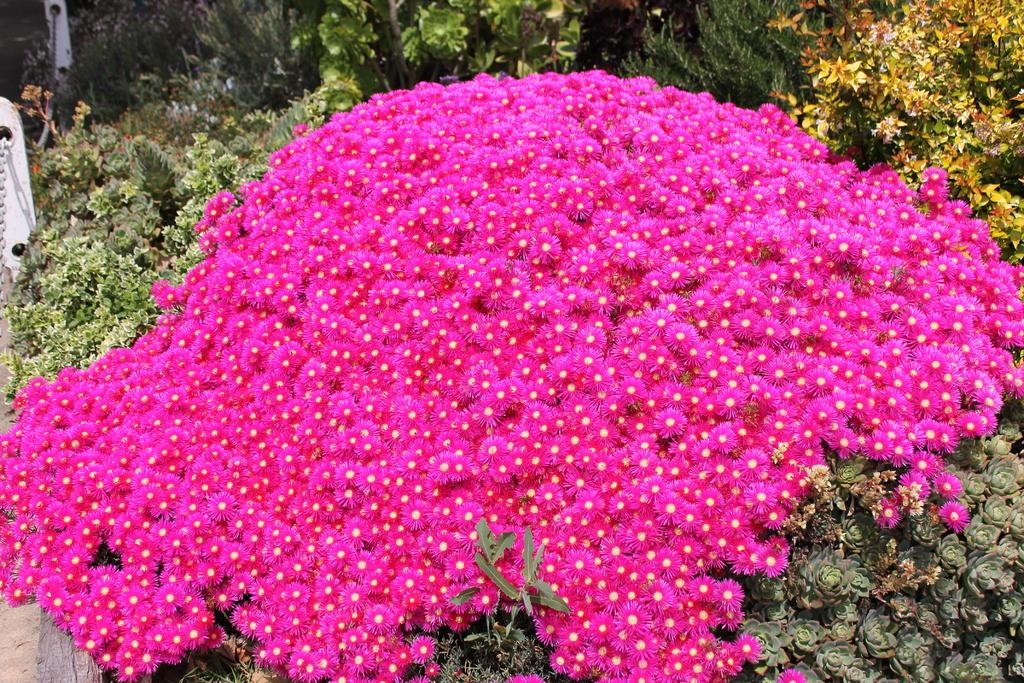What is the main subject of the image? The main subject of the image is a bunch of flowers. Are there any other plants visible in the image? Yes, there are plants with green leaves in the image. What is the title of the book that is being read by the flowers in the image? There is no book or reading depicted in the image; it features a bunch of flowers and plants with green leaves. 